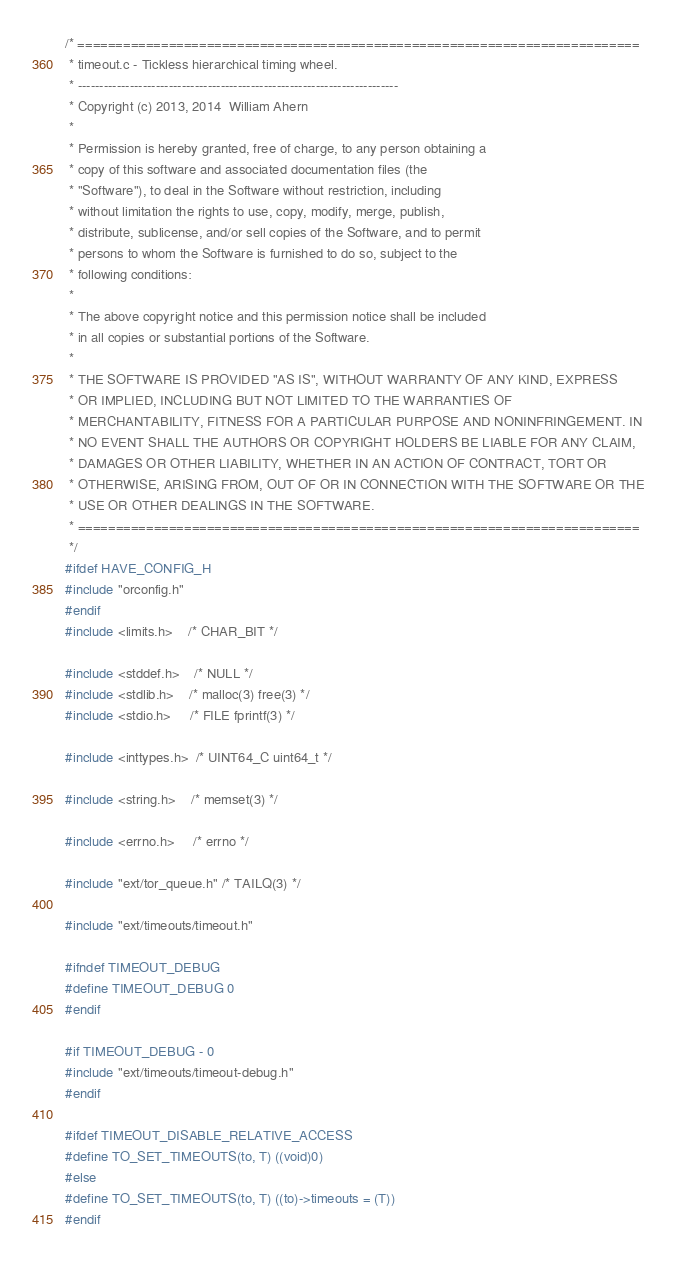<code> <loc_0><loc_0><loc_500><loc_500><_C_>/* ==========================================================================
 * timeout.c - Tickless hierarchical timing wheel.
 * --------------------------------------------------------------------------
 * Copyright (c) 2013, 2014  William Ahern
 *
 * Permission is hereby granted, free of charge, to any person obtaining a
 * copy of this software and associated documentation files (the
 * "Software"), to deal in the Software without restriction, including
 * without limitation the rights to use, copy, modify, merge, publish,
 * distribute, sublicense, and/or sell copies of the Software, and to permit
 * persons to whom the Software is furnished to do so, subject to the
 * following conditions:
 *
 * The above copyright notice and this permission notice shall be included
 * in all copies or substantial portions of the Software.
 *
 * THE SOFTWARE IS PROVIDED "AS IS", WITHOUT WARRANTY OF ANY KIND, EXPRESS
 * OR IMPLIED, INCLUDING BUT NOT LIMITED TO THE WARRANTIES OF
 * MERCHANTABILITY, FITNESS FOR A PARTICULAR PURPOSE AND NONINFRINGEMENT. IN
 * NO EVENT SHALL THE AUTHORS OR COPYRIGHT HOLDERS BE LIABLE FOR ANY CLAIM,
 * DAMAGES OR OTHER LIABILITY, WHETHER IN AN ACTION OF CONTRACT, TORT OR
 * OTHERWISE, ARISING FROM, OUT OF OR IN CONNECTION WITH THE SOFTWARE OR THE
 * USE OR OTHER DEALINGS IN THE SOFTWARE.
 * ==========================================================================
 */
#ifdef HAVE_CONFIG_H
#include "orconfig.h"
#endif
#include <limits.h>    /* CHAR_BIT */

#include <stddef.h>    /* NULL */
#include <stdlib.h>    /* malloc(3) free(3) */
#include <stdio.h>     /* FILE fprintf(3) */

#include <inttypes.h>  /* UINT64_C uint64_t */

#include <string.h>    /* memset(3) */

#include <errno.h>     /* errno */

#include "ext/tor_queue.h" /* TAILQ(3) */

#include "ext/timeouts/timeout.h"

#ifndef TIMEOUT_DEBUG
#define TIMEOUT_DEBUG 0
#endif

#if TIMEOUT_DEBUG - 0
#include "ext/timeouts/timeout-debug.h"
#endif

#ifdef TIMEOUT_DISABLE_RELATIVE_ACCESS
#define TO_SET_TIMEOUTS(to, T) ((void)0)
#else
#define TO_SET_TIMEOUTS(to, T) ((to)->timeouts = (T))
#endif
</code> 